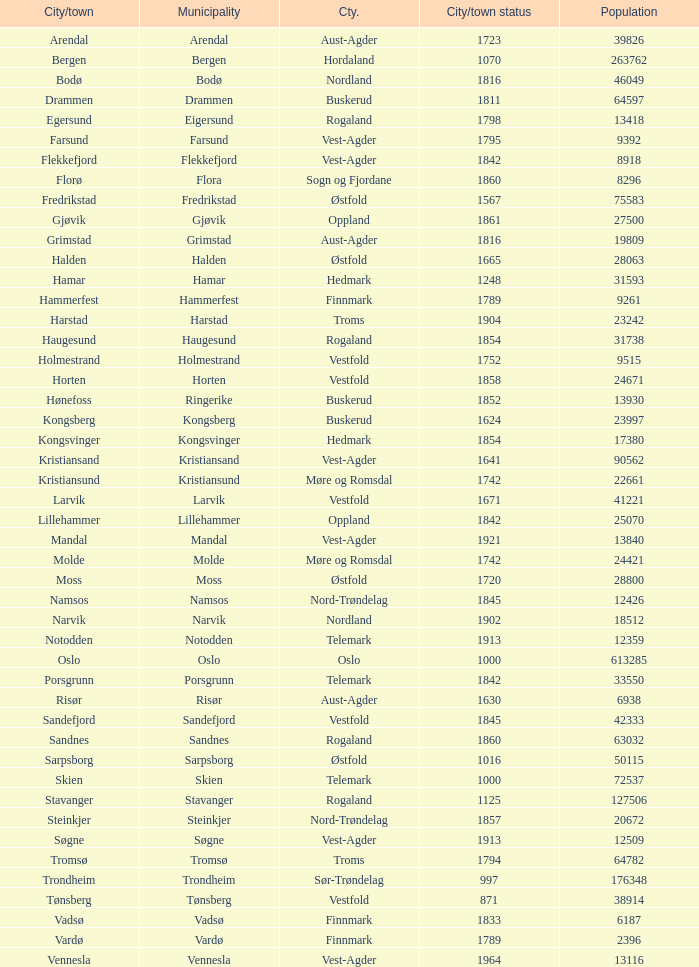In which municipality is the population 24,421? Molde. 